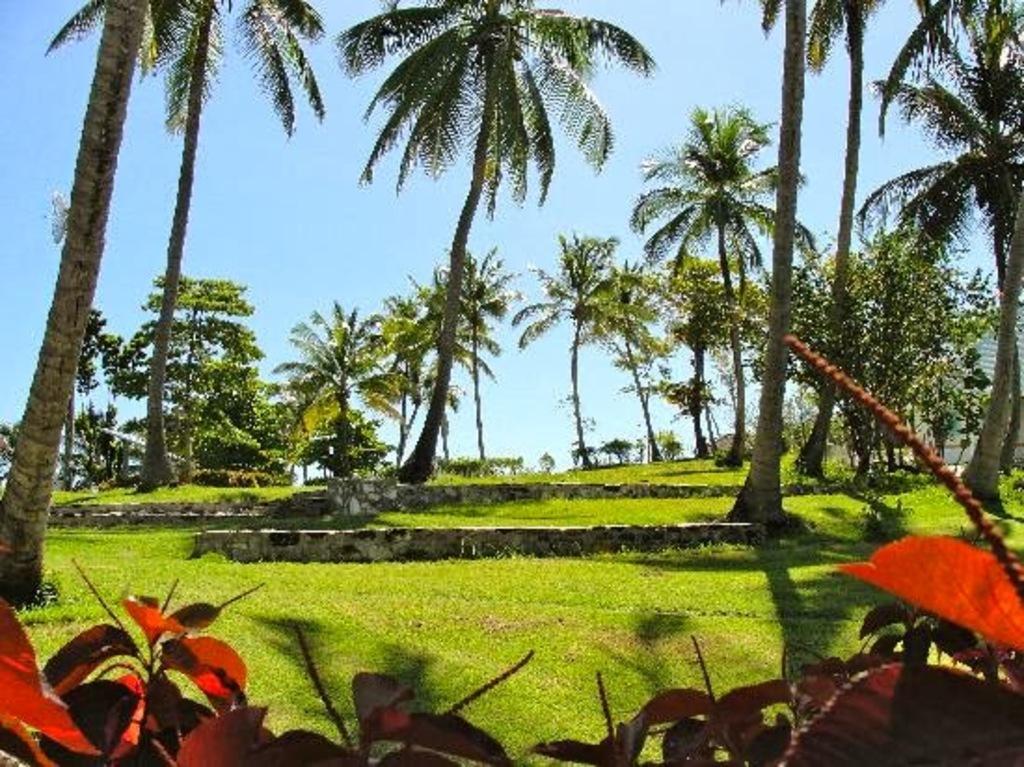Could you give a brief overview of what you see in this image? This is an outside view. At the bottom few leaves are visible. On the ground, I can see the grass. In the background there are many trees. At the top of the image I can see the sky. 